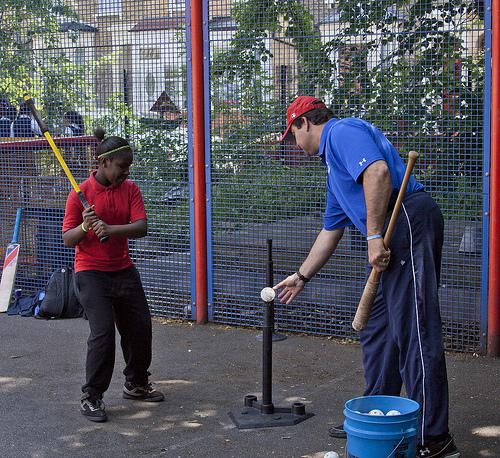Question: when was this picture taken?
Choices:
A. Nighting.
B. Evening.
C. Morning.
D. Daytime.
Answer with the letter. Answer: D Question: where was this picture taken?
Choices:
A. A park.
B. A school.
C. At home.
D. Outside.
Answer with the letter. Answer: A Question: what color is the bucket of balls?
Choices:
A. Red.
B. White.
C. Blue.
D. Green.
Answer with the letter. Answer: C Question: what sport is being practiced here?
Choices:
A. Basketball.
B. Softball.
C. Tennis.
D. Baseball.
Answer with the letter. Answer: D Question: who is placing the ball on the stand?
Choices:
A. The woman.
B. The child.
C. The bear.
D. The man.
Answer with the letter. Answer: D 